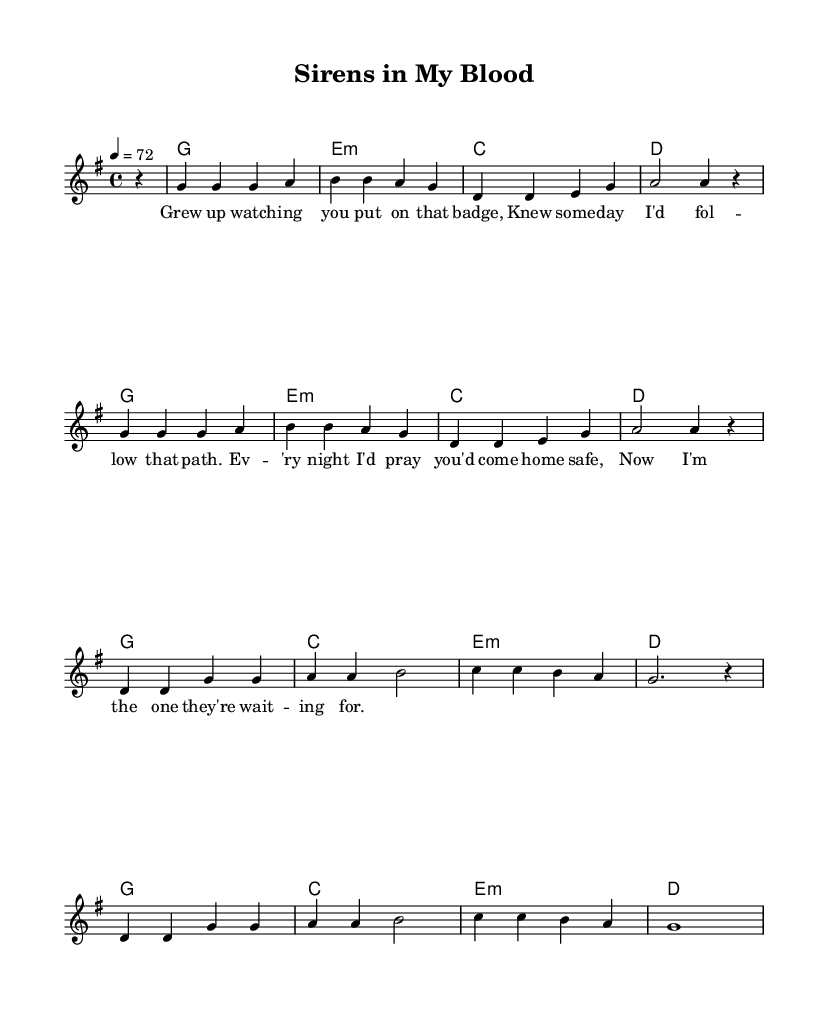What is the key signature of this music? The key signature is G major, which has one sharp (F#).
Answer: G major What is the time signature of the piece? The time signature is 4/4, indicating four beats per measure.
Answer: 4/4 What is the tempo marking for the piece? The tempo marking is 72 beats per minute, indicating a moderate pace.
Answer: 72 How many measures are in the melody section? The melody section contains 16 measures, based on the number of bar lines present.
Answer: 16 What is the first note of the melody? The first note of the melody is a G. This can be determined by examining the first note in the melody line.
Answer: G How many times does the phrase "g g g a" appear in the melody? The phrase "g g g a" appears twice in the melody, specifically in the first and later sections.
Answer: 2 What emotional theme does the song convey? The song conveys a theme of dedication and following in a parent's footsteps, as indicated by the lyrics and context of the music.
Answer: Dedication 